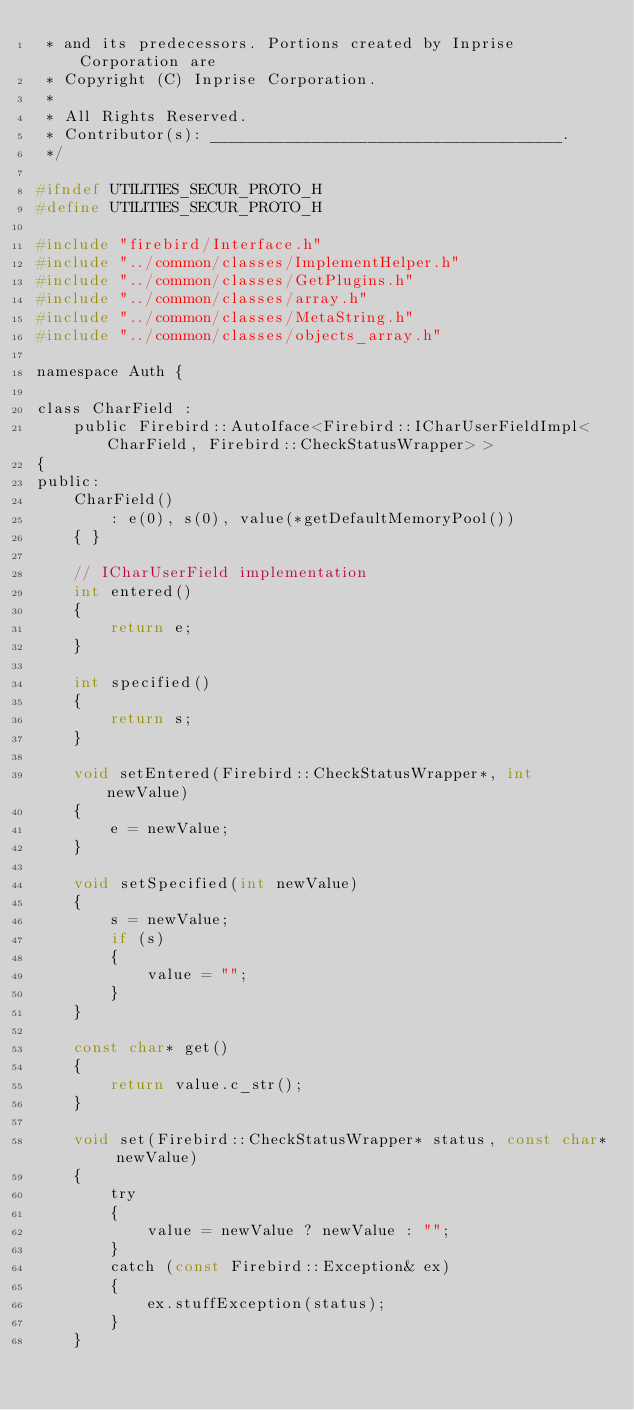<code> <loc_0><loc_0><loc_500><loc_500><_C_> * and its predecessors. Portions created by Inprise Corporation are
 * Copyright (C) Inprise Corporation.
 *
 * All Rights Reserved.
 * Contributor(s): ______________________________________.
 */

#ifndef UTILITIES_SECUR_PROTO_H
#define UTILITIES_SECUR_PROTO_H

#include "firebird/Interface.h"
#include "../common/classes/ImplementHelper.h"
#include "../common/classes/GetPlugins.h"
#include "../common/classes/array.h"
#include "../common/classes/MetaString.h"
#include "../common/classes/objects_array.h"

namespace Auth {

class CharField :
	public Firebird::AutoIface<Firebird::ICharUserFieldImpl<CharField, Firebird::CheckStatusWrapper> >
{
public:
	CharField()
		: e(0), s(0), value(*getDefaultMemoryPool())
	{ }

	// ICharUserField implementation
	int entered()
	{
		return e;
	}

	int specified()
	{
		return s;
	}

	void setEntered(Firebird::CheckStatusWrapper*, int newValue)
	{
		e = newValue;
	}

	void setSpecified(int newValue)
	{
		s = newValue;
		if (s)
		{
			value = "";
		}
	}

	const char* get()
	{
		return value.c_str();
	}

	void set(Firebird::CheckStatusWrapper* status, const char* newValue)
	{
		try
		{
			value = newValue ? newValue : "";
		}
		catch (const Firebird::Exception& ex)
		{
			ex.stuffException(status);
		}
	}
</code> 